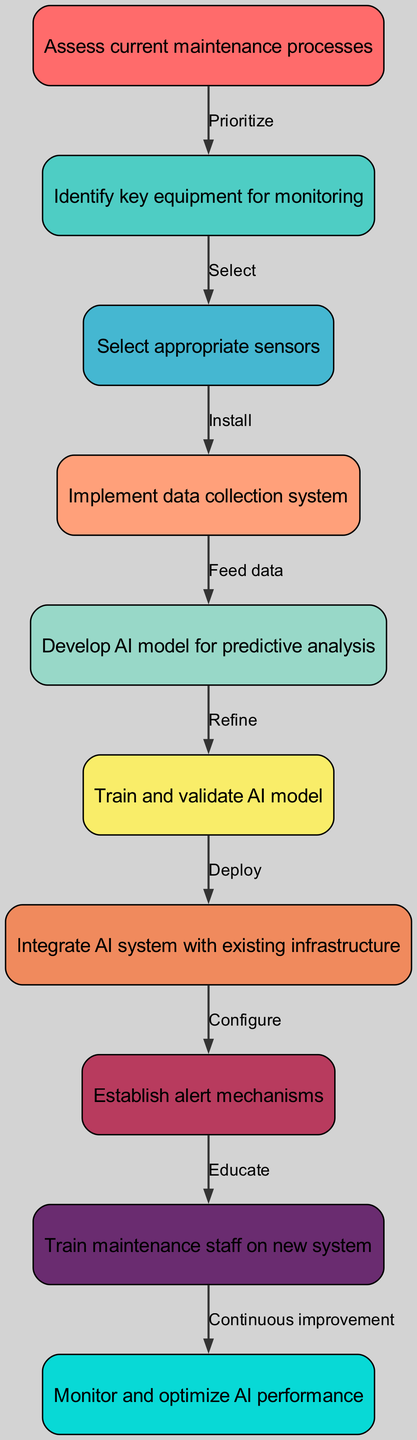What is the first step in the diagram? The first node in the diagram, which is at the top, is labeled "Assess current maintenance processes". It is the starting point of the flow.
Answer: Assess current maintenance processes How many nodes are there in total? By counting the individual nodes listed in the data, there are ten distinct nodes present in the diagram representing the steps in the process.
Answer: 10 What step follows the "Implement data collection system"? Looking at the edges in the diagram, after the node "Implement data collection system", the next step is "Develop AI model for predictive analysis".
Answer: Develop AI model for predictive analysis What action is taken after "Train maintenance staff on new system"? The diagram indicates that "Train maintenance staff on new system" leads directly to the action "Monitor and optimize AI performance", which is the following step.
Answer: Monitor and optimize AI performance Which node is directly connected to "Select appropriate sensors"? The flow shows that "Select appropriate sensors" connects directly to "Implement data collection system", meaning this is the next step after selecting sensors.
Answer: Implement data collection system What is the relationship type between "Establish alert mechanisms" and "Train maintenance staff on new system"? The data indicates that "Establish alert mechanisms" points to "Train maintenance staff on new system", and the connection is labeled "Educate", signifying an instructional relationship.
Answer: Educate Which node represents developing the AI model? The node titled "Develop AI model for predictive analysis" corresponds to the crucial step of creating the predictive model for the system.
Answer: Develop AI model for predictive analysis What step precedes the "Integrate AI system with existing infrastructure"? "Train and validate AI model" is directly connected to "Integrate AI system with existing infrastructure", making it the preceding step in the process.
Answer: Train and validate AI model Which sensor installation step leads to data collection? The connection from the node "Select appropriate sensors" to "Implement data collection system" indicates that after selecting the sensors, the next step is installing them for data collection purposes.
Answer: Implement data collection system How many edges link the nodes in the diagram? Counting the edges listed in the data reveals there are nine connections that link the steps in the flow of the predictive maintenance system development.
Answer: 9 